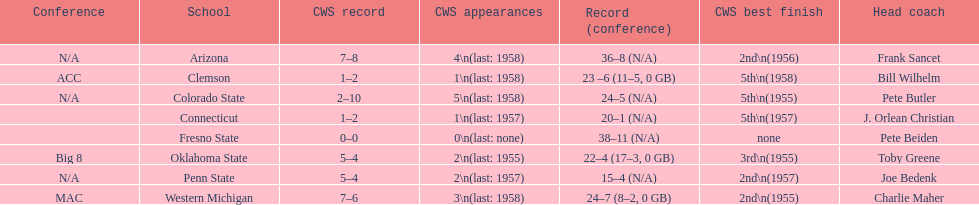Itemize every school that secured 2nd position in cws best finish. Arizona, Penn State, Western Michigan. 